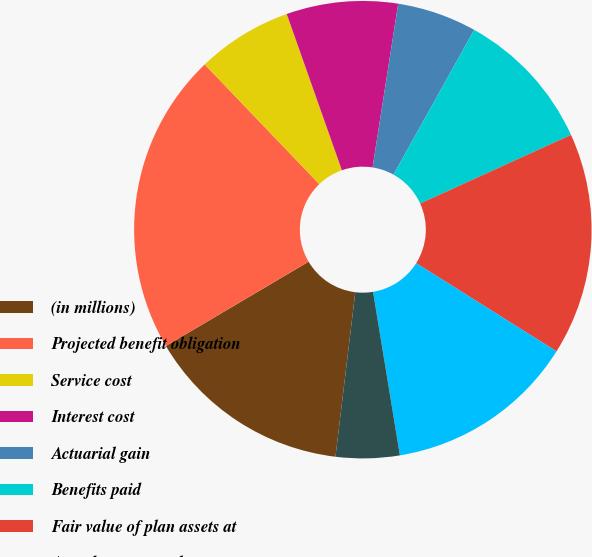Convert chart. <chart><loc_0><loc_0><loc_500><loc_500><pie_chart><fcel>(in millions)<fcel>Projected benefit obligation<fcel>Service cost<fcel>Interest cost<fcel>Actuarial gain<fcel>Benefits paid<fcel>Fair value of plan assets at<fcel>Actual return on plan assets<fcel>Employer contributions<nl><fcel>14.6%<fcel>21.34%<fcel>6.75%<fcel>7.87%<fcel>5.62%<fcel>10.11%<fcel>15.73%<fcel>13.48%<fcel>4.5%<nl></chart> 